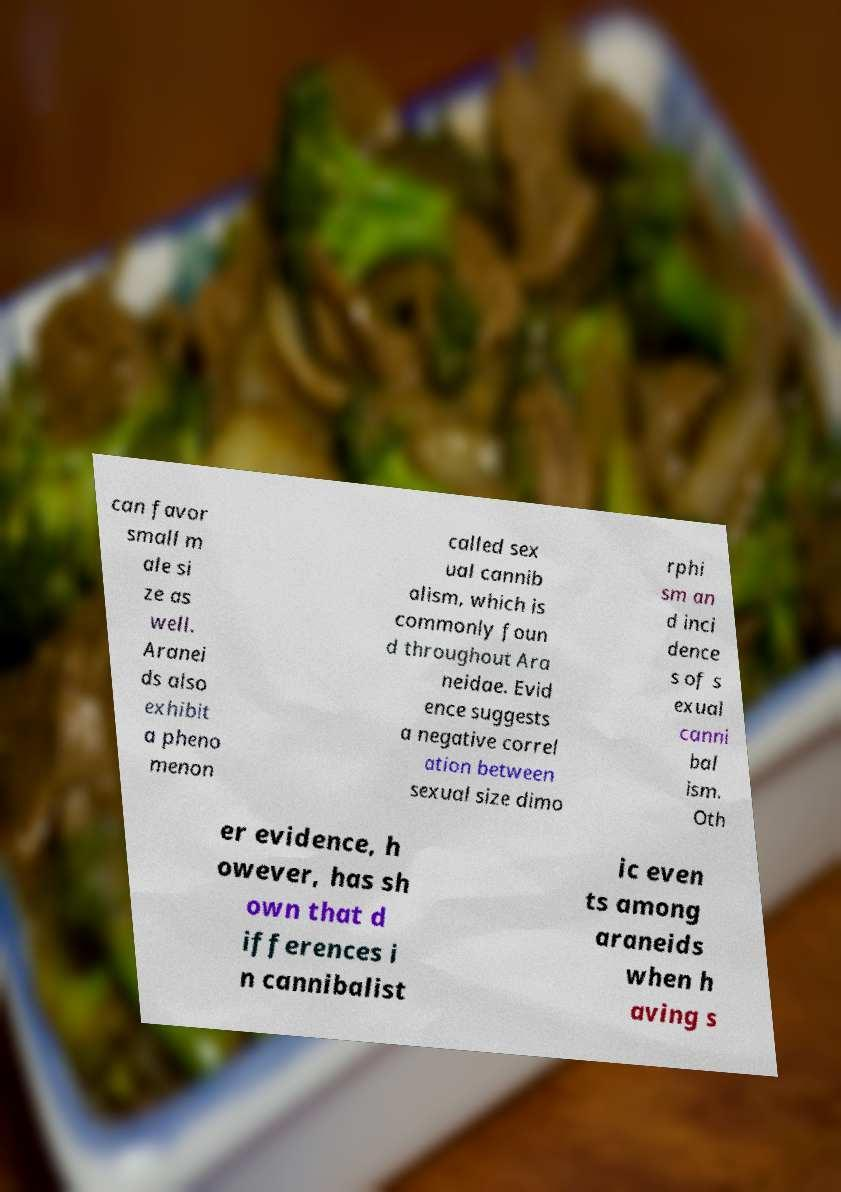Please identify and transcribe the text found in this image. can favor small m ale si ze as well. Aranei ds also exhibit a pheno menon called sex ual cannib alism, which is commonly foun d throughout Ara neidae. Evid ence suggests a negative correl ation between sexual size dimo rphi sm an d inci dence s of s exual canni bal ism. Oth er evidence, h owever, has sh own that d ifferences i n cannibalist ic even ts among araneids when h aving s 